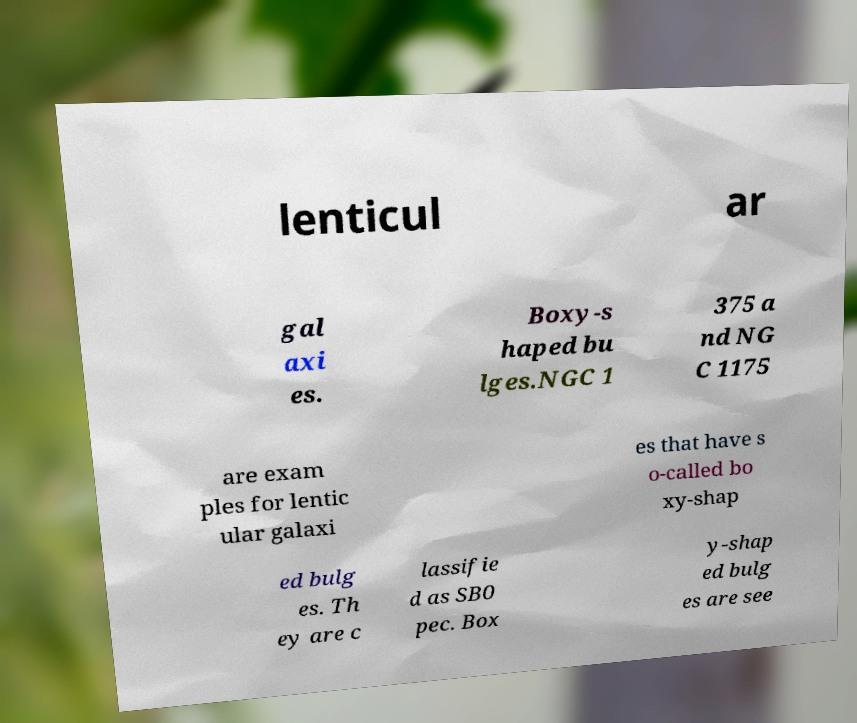There's text embedded in this image that I need extracted. Can you transcribe it verbatim? lenticul ar gal axi es. Boxy-s haped bu lges.NGC 1 375 a nd NG C 1175 are exam ples for lentic ular galaxi es that have s o-called bo xy-shap ed bulg es. Th ey are c lassifie d as SB0 pec. Box y-shap ed bulg es are see 